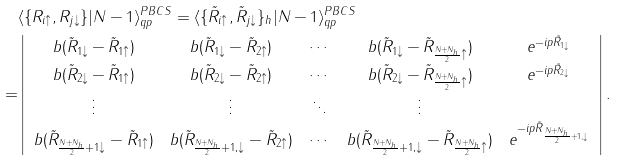<formula> <loc_0><loc_0><loc_500><loc_500>& \langle \{ R _ { i \uparrow } , R _ { j \downarrow } \} | N - 1 \rangle _ { q p } ^ { P B C S } = \langle \{ \tilde { R } _ { i \uparrow } , \tilde { R } _ { j \downarrow } \} _ { h } | N - 1 \rangle _ { q p } ^ { P B C S } \\ = & \left | \begin{array} { c c c c c } b ( \tilde { R } _ { 1 \downarrow } - \tilde { R } _ { 1 \uparrow } ) & b ( \tilde { R } _ { 1 \downarrow } - \tilde { R } _ { 2 \uparrow } ) & \cdots & b ( \tilde { R } _ { 1 \downarrow } - \tilde { R } _ { \frac { N + N _ { h } } { 2 } \uparrow } ) & e ^ { - i p \tilde { R } _ { 1 \downarrow } } \\ b ( \tilde { R } _ { 2 \downarrow } - \tilde { R } _ { 1 \uparrow } ) & b ( \tilde { R } _ { 2 \downarrow } - \tilde { R } _ { 2 \uparrow } ) & \cdots & b ( \tilde { R } _ { 2 \downarrow } - \tilde { R } _ { \frac { N + N _ { h } } { 2 } \uparrow } ) & e ^ { - i p \tilde { R } _ { 2 \downarrow } } \\ \vdots & \vdots & \ddots & \vdots \\ b ( \tilde { R } _ { \frac { N + N _ { h } } { 2 } + 1 \downarrow } - \tilde { R } _ { 1 \uparrow } ) & b ( \tilde { R } _ { \frac { N + N _ { h } } { 2 } + 1 , \downarrow } - \tilde { R } _ { 2 \uparrow } ) & \cdots & b ( \tilde { R } _ { \frac { N + N _ { h } } { 2 } + 1 , \downarrow } - \tilde { R } _ { \frac { N + N _ { h } } { 2 } \uparrow } ) & e ^ { - i p \tilde { R } _ { \frac { N + N _ { h } } { 2 } + 1 , \downarrow } } \end{array} \right | .</formula> 